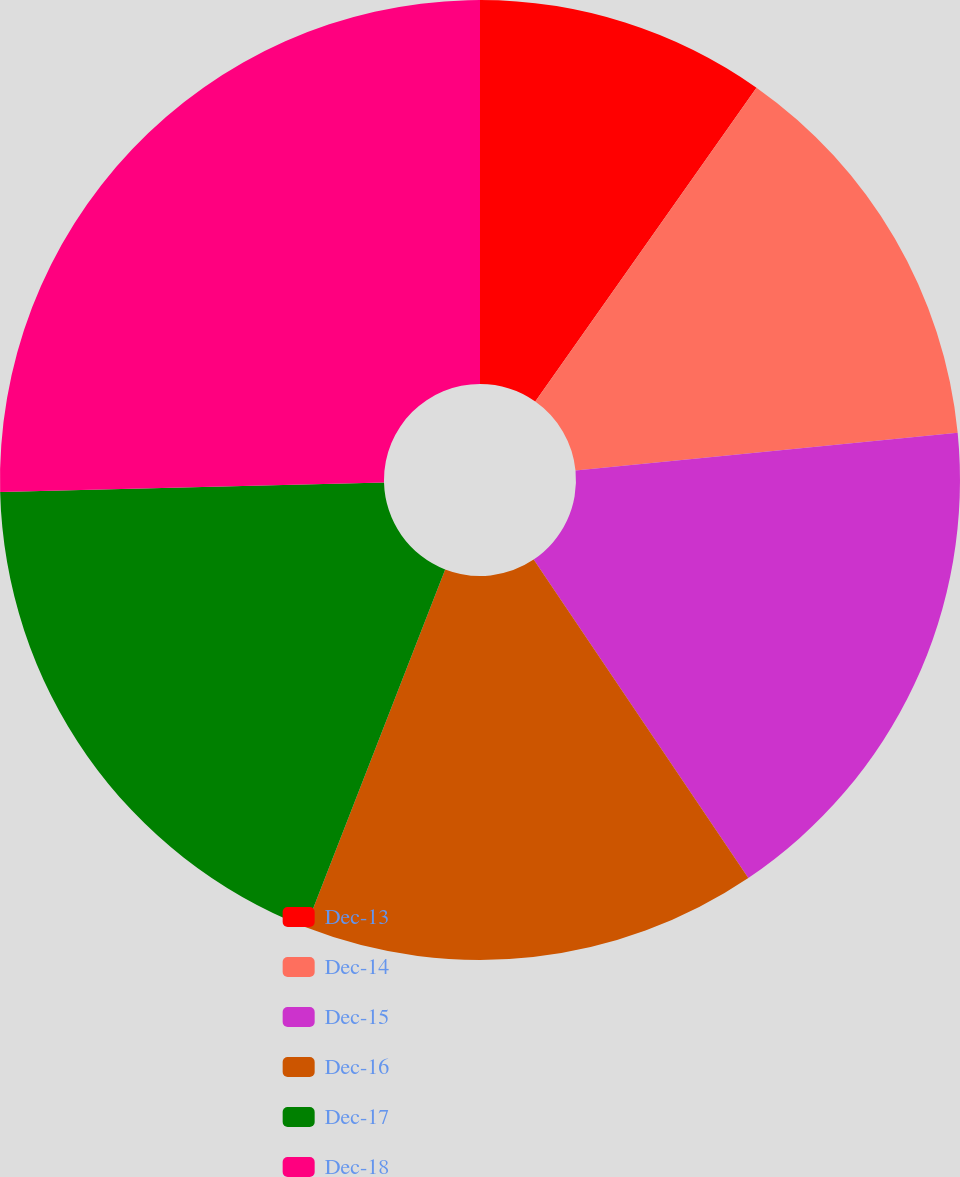Convert chart. <chart><loc_0><loc_0><loc_500><loc_500><pie_chart><fcel>Dec-13<fcel>Dec-14<fcel>Dec-15<fcel>Dec-16<fcel>Dec-17<fcel>Dec-18<nl><fcel>9.77%<fcel>13.66%<fcel>17.13%<fcel>15.35%<fcel>18.69%<fcel>25.4%<nl></chart> 